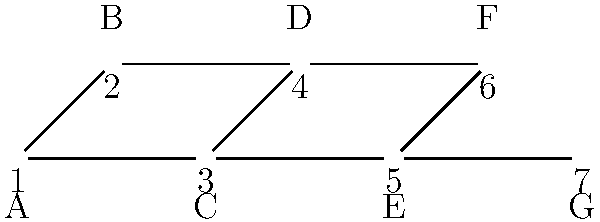Consider the family tree of Spanish nobility represented by the graph above, where each node represents a noble family and edges represent direct bloodline connections. What is the maximum number of non-overlapping bloodlines (i.e., the size of the maximum independent set) in this family tree? To find the maximum number of non-overlapping bloodlines, we need to determine the size of the maximum independent set in the graph. An independent set is a set of vertices in a graph, no two of which are adjacent. In the context of bloodlines, this means selecting noble families that are not directly connected.

Let's approach this step-by-step:

1) First, observe that the graph is bipartite, with nodes divided into two sets: {A, C, E, G} and {B, D, F}.

2) In a bipartite graph, the size of the maximum independent set is equal to the number of vertices minus the size of the maximum matching.

3) To find the maximum matching, we can use the following greedy approach:
   - Select edge A-B
   - Select edge C-D
   - Select edge E-F
   
4) The maximum matching has 3 edges, connecting 6 vertices.

5) The total number of vertices in the graph is 7.

6) Therefore, the size of the maximum independent set is:
   7 (total vertices) - 6 (vertices in maximum matching) = 1

7) We can verify this result by observing that G is the only vertex that can be selected without conflicting with the others.

Thus, the maximum number of non-overlapping bloodlines in this family tree is 1.
Answer: 1 